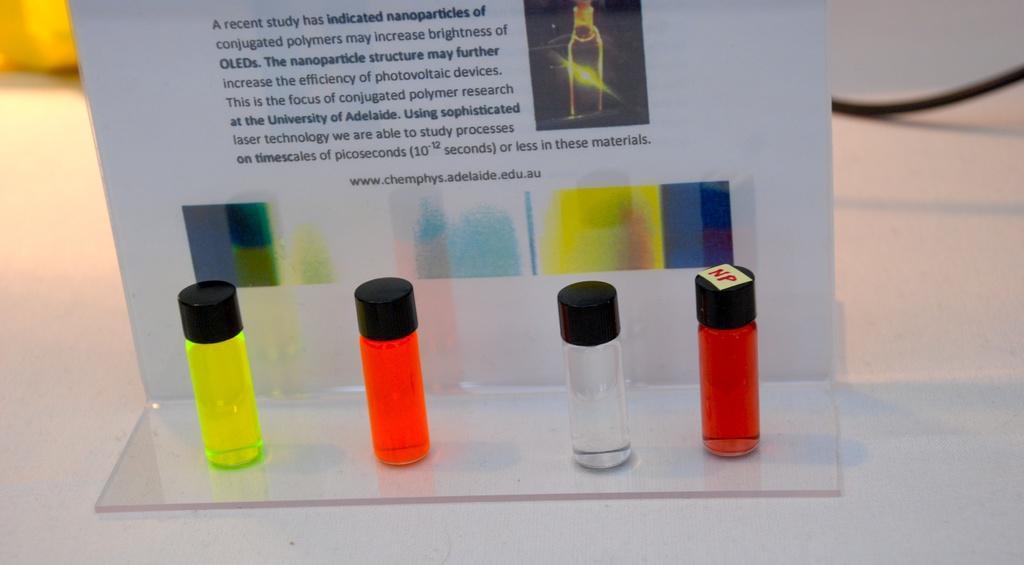Please provide a concise description of this image. In the image we can see there are four small bottles which are in different colours and on the bottle its written "NP" on a yellow plane paper and at the back there is a hoarding on which there is a matter written about the bottles. 